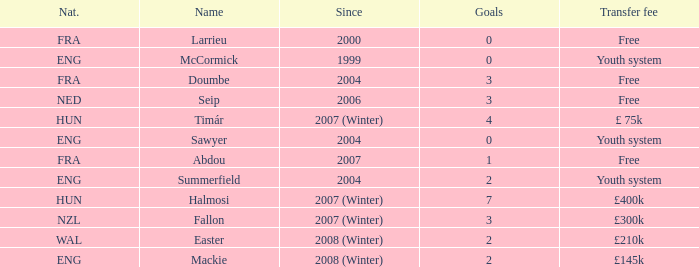Help me parse the entirety of this table. {'header': ['Nat.', 'Name', 'Since', 'Goals', 'Transfer fee'], 'rows': [['FRA', 'Larrieu', '2000', '0', 'Free'], ['ENG', 'McCormick', '1999', '0', 'Youth system'], ['FRA', 'Doumbe', '2004', '3', 'Free'], ['NED', 'Seip', '2006', '3', 'Free'], ['HUN', 'Timár', '2007 (Winter)', '4', '£ 75k'], ['ENG', 'Sawyer', '2004', '0', 'Youth system'], ['FRA', 'Abdou', '2007', '1', 'Free'], ['ENG', 'Summerfield', '2004', '2', 'Youth system'], ['HUN', 'Halmosi', '2007 (Winter)', '7', '£400k'], ['NZL', 'Fallon', '2007 (Winter)', '3', '£300k'], ['WAL', 'Easter', '2008 (Winter)', '2', '£210k'], ['ENG', 'Mackie', '2008 (Winter)', '2', '£145k']]} What is the average goals Sawyer has? 0.0. 